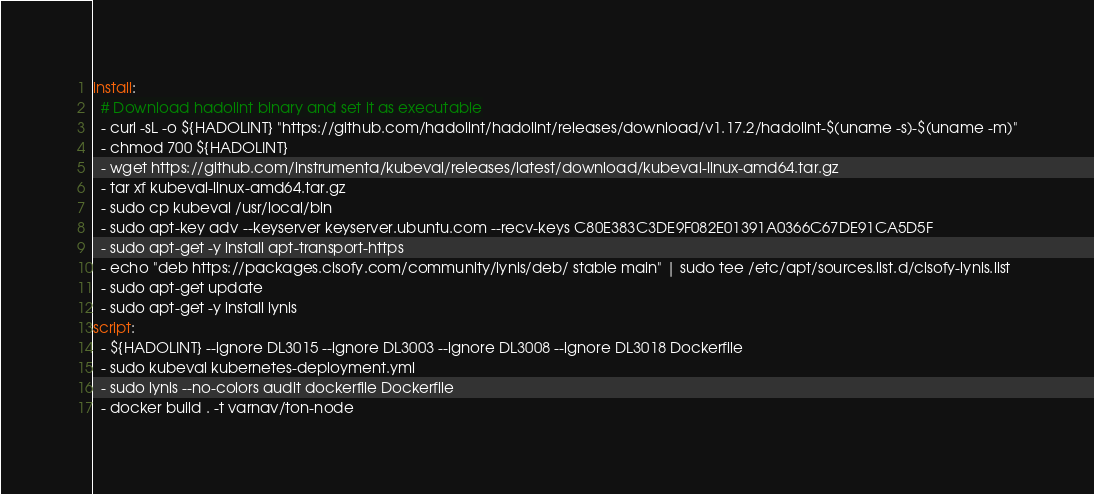<code> <loc_0><loc_0><loc_500><loc_500><_YAML_>install:
  # Download hadolint binary and set it as executable
  - curl -sL -o ${HADOLINT} "https://github.com/hadolint/hadolint/releases/download/v1.17.2/hadolint-$(uname -s)-$(uname -m)"
  - chmod 700 ${HADOLINT}
  - wget https://github.com/instrumenta/kubeval/releases/latest/download/kubeval-linux-amd64.tar.gz
  - tar xf kubeval-linux-amd64.tar.gz
  - sudo cp kubeval /usr/local/bin
  - sudo apt-key adv --keyserver keyserver.ubuntu.com --recv-keys C80E383C3DE9F082E01391A0366C67DE91CA5D5F
  - sudo apt-get -y install apt-transport-https
  - echo "deb https://packages.cisofy.com/community/lynis/deb/ stable main" | sudo tee /etc/apt/sources.list.d/cisofy-lynis.list
  - sudo apt-get update
  - sudo apt-get -y install lynis
script:
  - ${HADOLINT} --ignore DL3015 --ignore DL3003 --ignore DL3008 --ignore DL3018 Dockerfile
  - sudo kubeval kubernetes-deployment.yml
  - sudo lynis --no-colors audit dockerfile Dockerfile
  - docker build . -t varnav/ton-node
</code> 